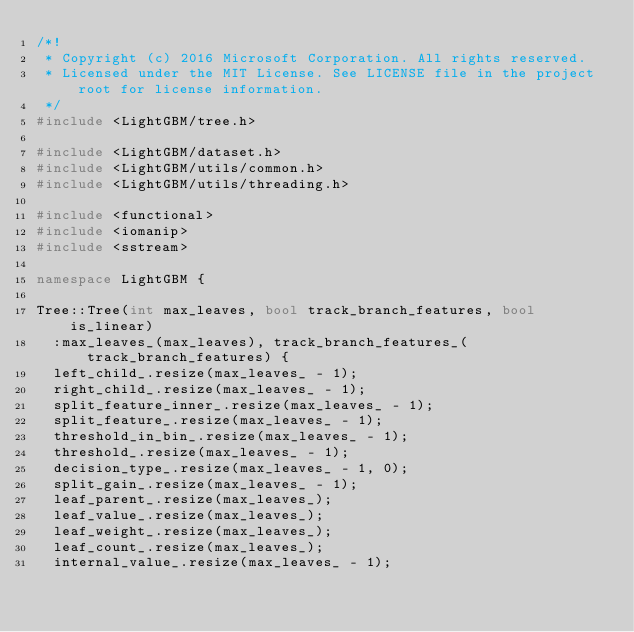<code> <loc_0><loc_0><loc_500><loc_500><_C++_>/*!
 * Copyright (c) 2016 Microsoft Corporation. All rights reserved.
 * Licensed under the MIT License. See LICENSE file in the project root for license information.
 */
#include <LightGBM/tree.h>

#include <LightGBM/dataset.h>
#include <LightGBM/utils/common.h>
#include <LightGBM/utils/threading.h>

#include <functional>
#include <iomanip>
#include <sstream>

namespace LightGBM {

Tree::Tree(int max_leaves, bool track_branch_features, bool is_linear)
  :max_leaves_(max_leaves), track_branch_features_(track_branch_features) {
  left_child_.resize(max_leaves_ - 1);
  right_child_.resize(max_leaves_ - 1);
  split_feature_inner_.resize(max_leaves_ - 1);
  split_feature_.resize(max_leaves_ - 1);
  threshold_in_bin_.resize(max_leaves_ - 1);
  threshold_.resize(max_leaves_ - 1);
  decision_type_.resize(max_leaves_ - 1, 0);
  split_gain_.resize(max_leaves_ - 1);
  leaf_parent_.resize(max_leaves_);
  leaf_value_.resize(max_leaves_);
  leaf_weight_.resize(max_leaves_);
  leaf_count_.resize(max_leaves_);
  internal_value_.resize(max_leaves_ - 1);</code> 